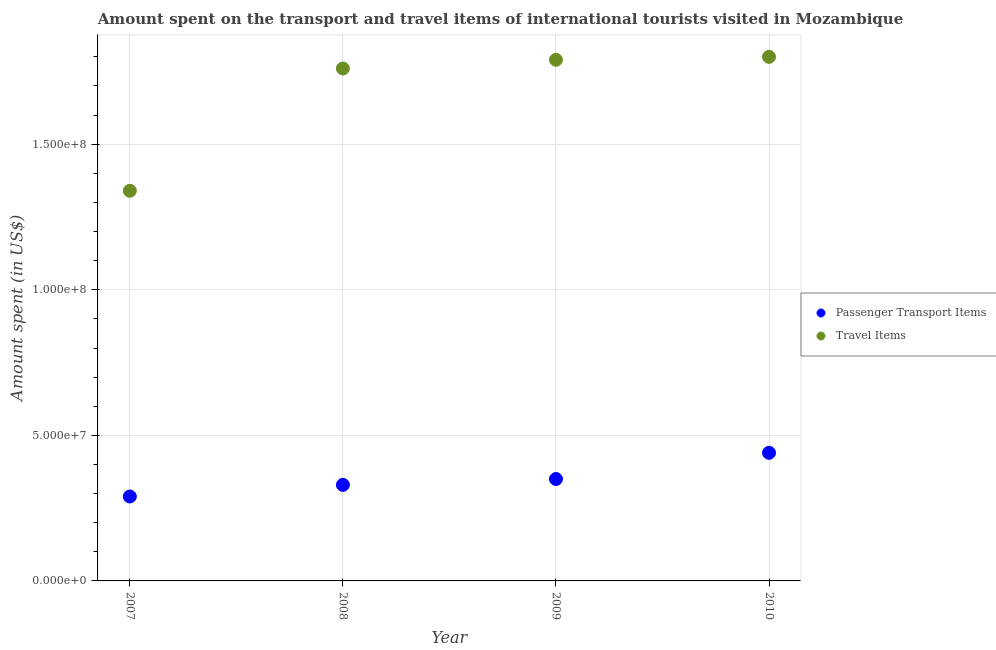Is the number of dotlines equal to the number of legend labels?
Keep it short and to the point. Yes. What is the amount spent on passenger transport items in 2007?
Provide a short and direct response. 2.90e+07. Across all years, what is the maximum amount spent in travel items?
Your answer should be compact. 1.80e+08. Across all years, what is the minimum amount spent on passenger transport items?
Make the answer very short. 2.90e+07. In which year was the amount spent in travel items minimum?
Provide a succinct answer. 2007. What is the total amount spent on passenger transport items in the graph?
Provide a short and direct response. 1.41e+08. What is the difference between the amount spent on passenger transport items in 2007 and that in 2008?
Offer a very short reply. -4.00e+06. What is the difference between the amount spent in travel items in 2007 and the amount spent on passenger transport items in 2010?
Give a very brief answer. 9.00e+07. What is the average amount spent on passenger transport items per year?
Your answer should be very brief. 3.52e+07. In the year 2009, what is the difference between the amount spent on passenger transport items and amount spent in travel items?
Your answer should be very brief. -1.44e+08. What is the ratio of the amount spent in travel items in 2008 to that in 2010?
Ensure brevity in your answer.  0.98. Is the difference between the amount spent on passenger transport items in 2008 and 2009 greater than the difference between the amount spent in travel items in 2008 and 2009?
Your response must be concise. Yes. What is the difference between the highest and the lowest amount spent on passenger transport items?
Your answer should be very brief. 1.50e+07. Does the amount spent in travel items monotonically increase over the years?
Your response must be concise. Yes. Is the amount spent on passenger transport items strictly less than the amount spent in travel items over the years?
Ensure brevity in your answer.  Yes. How many years are there in the graph?
Give a very brief answer. 4. What is the difference between two consecutive major ticks on the Y-axis?
Provide a short and direct response. 5.00e+07. Where does the legend appear in the graph?
Ensure brevity in your answer.  Center right. How are the legend labels stacked?
Your answer should be very brief. Vertical. What is the title of the graph?
Your answer should be very brief. Amount spent on the transport and travel items of international tourists visited in Mozambique. Does "Banks" appear as one of the legend labels in the graph?
Offer a terse response. No. What is the label or title of the Y-axis?
Your answer should be very brief. Amount spent (in US$). What is the Amount spent (in US$) of Passenger Transport Items in 2007?
Provide a short and direct response. 2.90e+07. What is the Amount spent (in US$) of Travel Items in 2007?
Give a very brief answer. 1.34e+08. What is the Amount spent (in US$) of Passenger Transport Items in 2008?
Keep it short and to the point. 3.30e+07. What is the Amount spent (in US$) in Travel Items in 2008?
Offer a terse response. 1.76e+08. What is the Amount spent (in US$) of Passenger Transport Items in 2009?
Your response must be concise. 3.50e+07. What is the Amount spent (in US$) in Travel Items in 2009?
Provide a succinct answer. 1.79e+08. What is the Amount spent (in US$) of Passenger Transport Items in 2010?
Make the answer very short. 4.40e+07. What is the Amount spent (in US$) of Travel Items in 2010?
Give a very brief answer. 1.80e+08. Across all years, what is the maximum Amount spent (in US$) in Passenger Transport Items?
Ensure brevity in your answer.  4.40e+07. Across all years, what is the maximum Amount spent (in US$) in Travel Items?
Offer a terse response. 1.80e+08. Across all years, what is the minimum Amount spent (in US$) of Passenger Transport Items?
Your answer should be very brief. 2.90e+07. Across all years, what is the minimum Amount spent (in US$) in Travel Items?
Your answer should be compact. 1.34e+08. What is the total Amount spent (in US$) of Passenger Transport Items in the graph?
Provide a succinct answer. 1.41e+08. What is the total Amount spent (in US$) of Travel Items in the graph?
Ensure brevity in your answer.  6.69e+08. What is the difference between the Amount spent (in US$) in Travel Items in 2007 and that in 2008?
Your answer should be very brief. -4.20e+07. What is the difference between the Amount spent (in US$) of Passenger Transport Items in 2007 and that in 2009?
Give a very brief answer. -6.00e+06. What is the difference between the Amount spent (in US$) of Travel Items in 2007 and that in 2009?
Your response must be concise. -4.50e+07. What is the difference between the Amount spent (in US$) in Passenger Transport Items in 2007 and that in 2010?
Offer a very short reply. -1.50e+07. What is the difference between the Amount spent (in US$) of Travel Items in 2007 and that in 2010?
Your answer should be compact. -4.60e+07. What is the difference between the Amount spent (in US$) of Passenger Transport Items in 2008 and that in 2009?
Offer a very short reply. -2.00e+06. What is the difference between the Amount spent (in US$) in Passenger Transport Items in 2008 and that in 2010?
Provide a succinct answer. -1.10e+07. What is the difference between the Amount spent (in US$) in Travel Items in 2008 and that in 2010?
Ensure brevity in your answer.  -4.00e+06. What is the difference between the Amount spent (in US$) of Passenger Transport Items in 2009 and that in 2010?
Give a very brief answer. -9.00e+06. What is the difference between the Amount spent (in US$) in Travel Items in 2009 and that in 2010?
Your answer should be very brief. -1.00e+06. What is the difference between the Amount spent (in US$) in Passenger Transport Items in 2007 and the Amount spent (in US$) in Travel Items in 2008?
Offer a terse response. -1.47e+08. What is the difference between the Amount spent (in US$) in Passenger Transport Items in 2007 and the Amount spent (in US$) in Travel Items in 2009?
Make the answer very short. -1.50e+08. What is the difference between the Amount spent (in US$) of Passenger Transport Items in 2007 and the Amount spent (in US$) of Travel Items in 2010?
Your answer should be very brief. -1.51e+08. What is the difference between the Amount spent (in US$) in Passenger Transport Items in 2008 and the Amount spent (in US$) in Travel Items in 2009?
Make the answer very short. -1.46e+08. What is the difference between the Amount spent (in US$) of Passenger Transport Items in 2008 and the Amount spent (in US$) of Travel Items in 2010?
Make the answer very short. -1.47e+08. What is the difference between the Amount spent (in US$) of Passenger Transport Items in 2009 and the Amount spent (in US$) of Travel Items in 2010?
Your answer should be very brief. -1.45e+08. What is the average Amount spent (in US$) of Passenger Transport Items per year?
Keep it short and to the point. 3.52e+07. What is the average Amount spent (in US$) in Travel Items per year?
Give a very brief answer. 1.67e+08. In the year 2007, what is the difference between the Amount spent (in US$) in Passenger Transport Items and Amount spent (in US$) in Travel Items?
Give a very brief answer. -1.05e+08. In the year 2008, what is the difference between the Amount spent (in US$) of Passenger Transport Items and Amount spent (in US$) of Travel Items?
Offer a terse response. -1.43e+08. In the year 2009, what is the difference between the Amount spent (in US$) in Passenger Transport Items and Amount spent (in US$) in Travel Items?
Provide a succinct answer. -1.44e+08. In the year 2010, what is the difference between the Amount spent (in US$) of Passenger Transport Items and Amount spent (in US$) of Travel Items?
Offer a terse response. -1.36e+08. What is the ratio of the Amount spent (in US$) in Passenger Transport Items in 2007 to that in 2008?
Offer a very short reply. 0.88. What is the ratio of the Amount spent (in US$) in Travel Items in 2007 to that in 2008?
Keep it short and to the point. 0.76. What is the ratio of the Amount spent (in US$) of Passenger Transport Items in 2007 to that in 2009?
Give a very brief answer. 0.83. What is the ratio of the Amount spent (in US$) of Travel Items in 2007 to that in 2009?
Your answer should be very brief. 0.75. What is the ratio of the Amount spent (in US$) in Passenger Transport Items in 2007 to that in 2010?
Ensure brevity in your answer.  0.66. What is the ratio of the Amount spent (in US$) of Travel Items in 2007 to that in 2010?
Ensure brevity in your answer.  0.74. What is the ratio of the Amount spent (in US$) in Passenger Transport Items in 2008 to that in 2009?
Your answer should be compact. 0.94. What is the ratio of the Amount spent (in US$) in Travel Items in 2008 to that in 2009?
Your answer should be very brief. 0.98. What is the ratio of the Amount spent (in US$) in Travel Items in 2008 to that in 2010?
Make the answer very short. 0.98. What is the ratio of the Amount spent (in US$) of Passenger Transport Items in 2009 to that in 2010?
Provide a succinct answer. 0.8. What is the difference between the highest and the second highest Amount spent (in US$) of Passenger Transport Items?
Offer a very short reply. 9.00e+06. What is the difference between the highest and the second highest Amount spent (in US$) in Travel Items?
Make the answer very short. 1.00e+06. What is the difference between the highest and the lowest Amount spent (in US$) in Passenger Transport Items?
Your answer should be compact. 1.50e+07. What is the difference between the highest and the lowest Amount spent (in US$) of Travel Items?
Ensure brevity in your answer.  4.60e+07. 